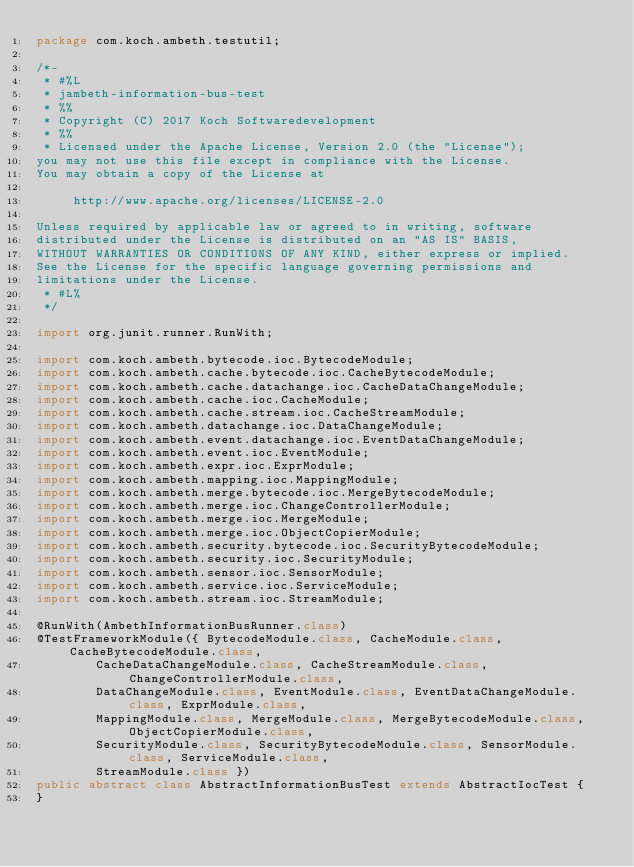Convert code to text. <code><loc_0><loc_0><loc_500><loc_500><_Java_>package com.koch.ambeth.testutil;

/*-
 * #%L
 * jambeth-information-bus-test
 * %%
 * Copyright (C) 2017 Koch Softwaredevelopment
 * %%
 * Licensed under the Apache License, Version 2.0 (the "License");
you may not use this file except in compliance with the License.
You may obtain a copy of the License at

     http://www.apache.org/licenses/LICENSE-2.0

Unless required by applicable law or agreed to in writing, software
distributed under the License is distributed on an "AS IS" BASIS,
WITHOUT WARRANTIES OR CONDITIONS OF ANY KIND, either express or implied.
See the License for the specific language governing permissions and
limitations under the License.
 * #L%
 */

import org.junit.runner.RunWith;

import com.koch.ambeth.bytecode.ioc.BytecodeModule;
import com.koch.ambeth.cache.bytecode.ioc.CacheBytecodeModule;
import com.koch.ambeth.cache.datachange.ioc.CacheDataChangeModule;
import com.koch.ambeth.cache.ioc.CacheModule;
import com.koch.ambeth.cache.stream.ioc.CacheStreamModule;
import com.koch.ambeth.datachange.ioc.DataChangeModule;
import com.koch.ambeth.event.datachange.ioc.EventDataChangeModule;
import com.koch.ambeth.event.ioc.EventModule;
import com.koch.ambeth.expr.ioc.ExprModule;
import com.koch.ambeth.mapping.ioc.MappingModule;
import com.koch.ambeth.merge.bytecode.ioc.MergeBytecodeModule;
import com.koch.ambeth.merge.ioc.ChangeControllerModule;
import com.koch.ambeth.merge.ioc.MergeModule;
import com.koch.ambeth.merge.ioc.ObjectCopierModule;
import com.koch.ambeth.security.bytecode.ioc.SecurityBytecodeModule;
import com.koch.ambeth.security.ioc.SecurityModule;
import com.koch.ambeth.sensor.ioc.SensorModule;
import com.koch.ambeth.service.ioc.ServiceModule;
import com.koch.ambeth.stream.ioc.StreamModule;

@RunWith(AmbethInformationBusRunner.class)
@TestFrameworkModule({ BytecodeModule.class, CacheModule.class, CacheBytecodeModule.class,
		CacheDataChangeModule.class, CacheStreamModule.class, ChangeControllerModule.class,
		DataChangeModule.class, EventModule.class, EventDataChangeModule.class, ExprModule.class,
		MappingModule.class, MergeModule.class, MergeBytecodeModule.class, ObjectCopierModule.class,
		SecurityModule.class, SecurityBytecodeModule.class, SensorModule.class, ServiceModule.class,
		StreamModule.class })
public abstract class AbstractInformationBusTest extends AbstractIocTest {
}
</code> 